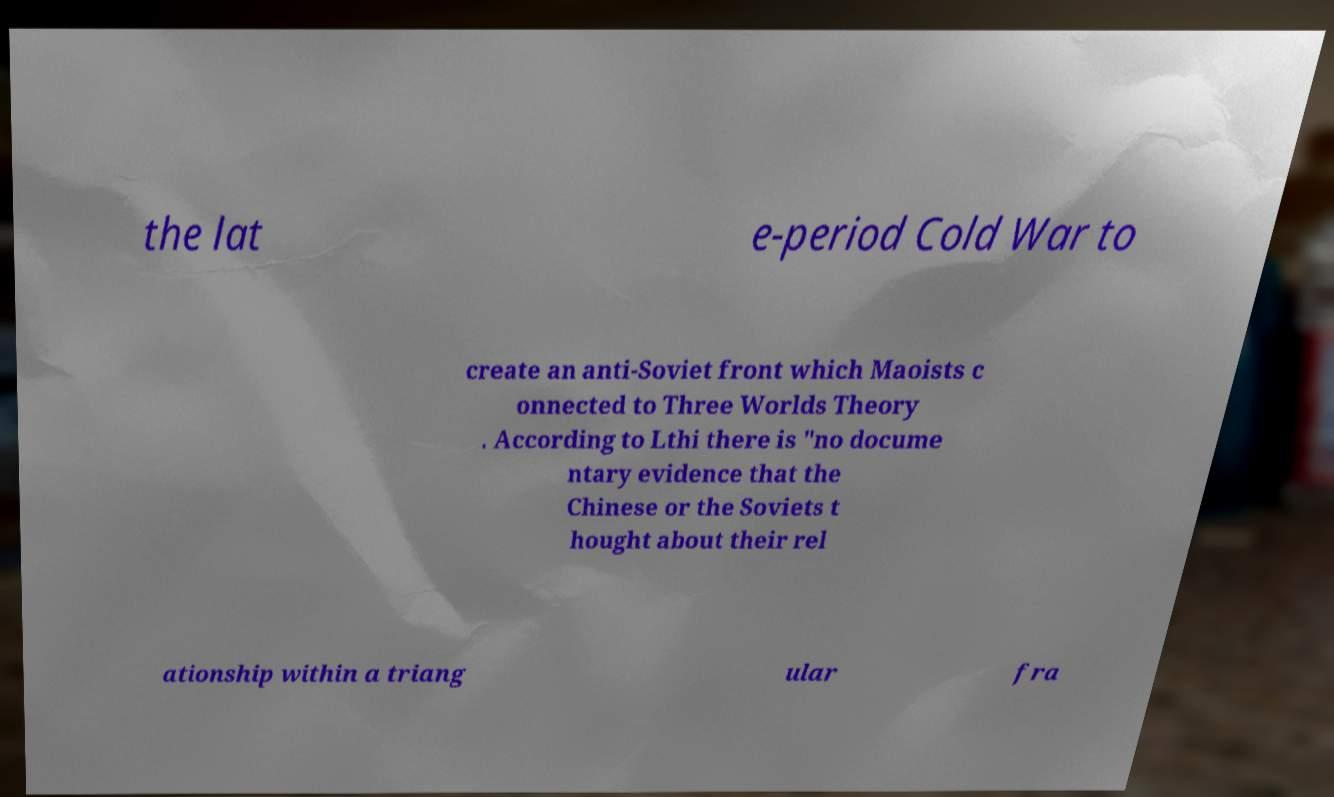There's text embedded in this image that I need extracted. Can you transcribe it verbatim? the lat e-period Cold War to create an anti-Soviet front which Maoists c onnected to Three Worlds Theory . According to Lthi there is "no docume ntary evidence that the Chinese or the Soviets t hought about their rel ationship within a triang ular fra 